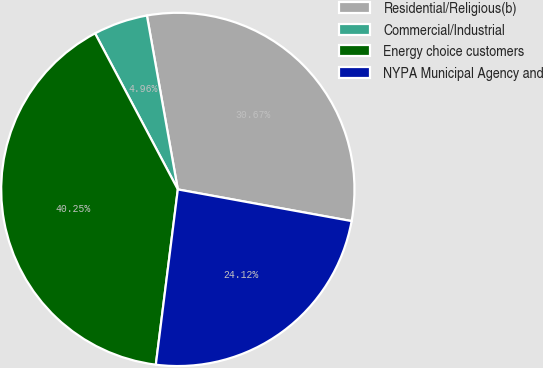Convert chart. <chart><loc_0><loc_0><loc_500><loc_500><pie_chart><fcel>Residential/Religious(b)<fcel>Commercial/Industrial<fcel>Energy choice customers<fcel>NYPA Municipal Agency and<nl><fcel>30.67%<fcel>4.96%<fcel>40.25%<fcel>24.12%<nl></chart> 